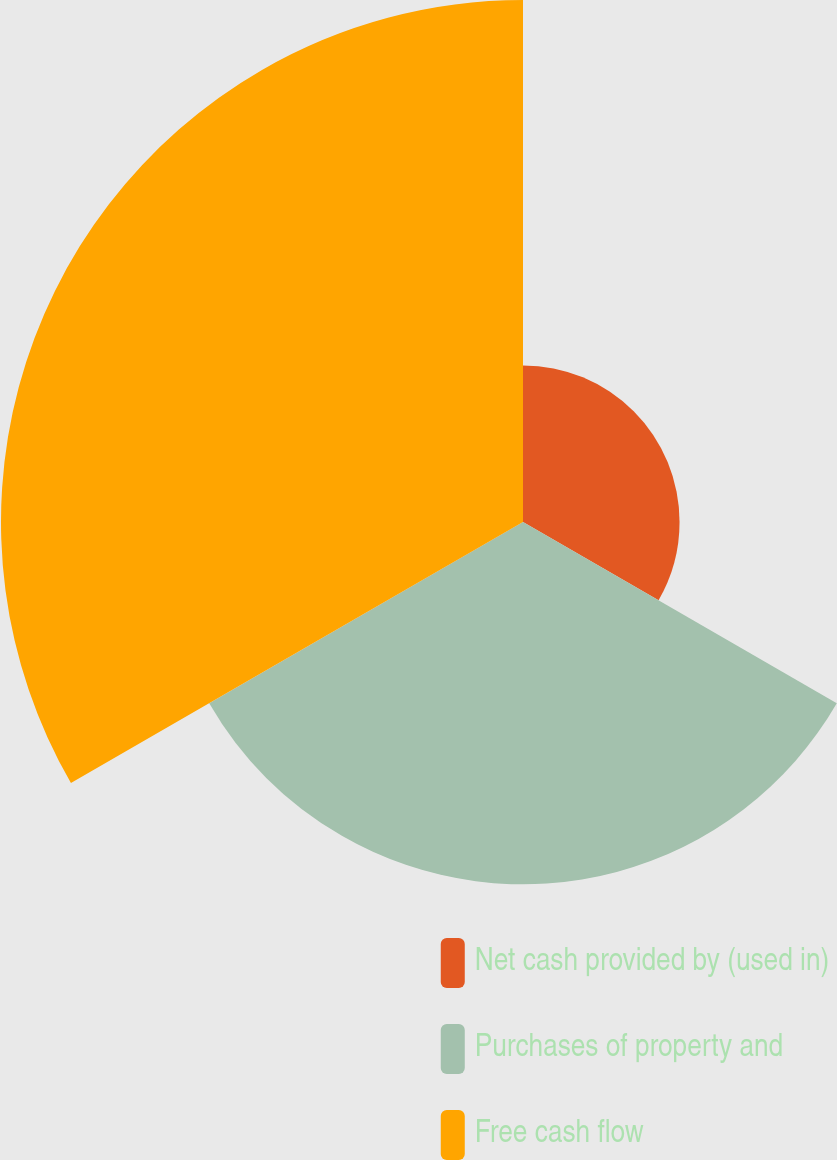<chart> <loc_0><loc_0><loc_500><loc_500><pie_chart><fcel>Net cash provided by (used in)<fcel>Purchases of property and<fcel>Free cash flow<nl><fcel>15.04%<fcel>34.81%<fcel>50.15%<nl></chart> 